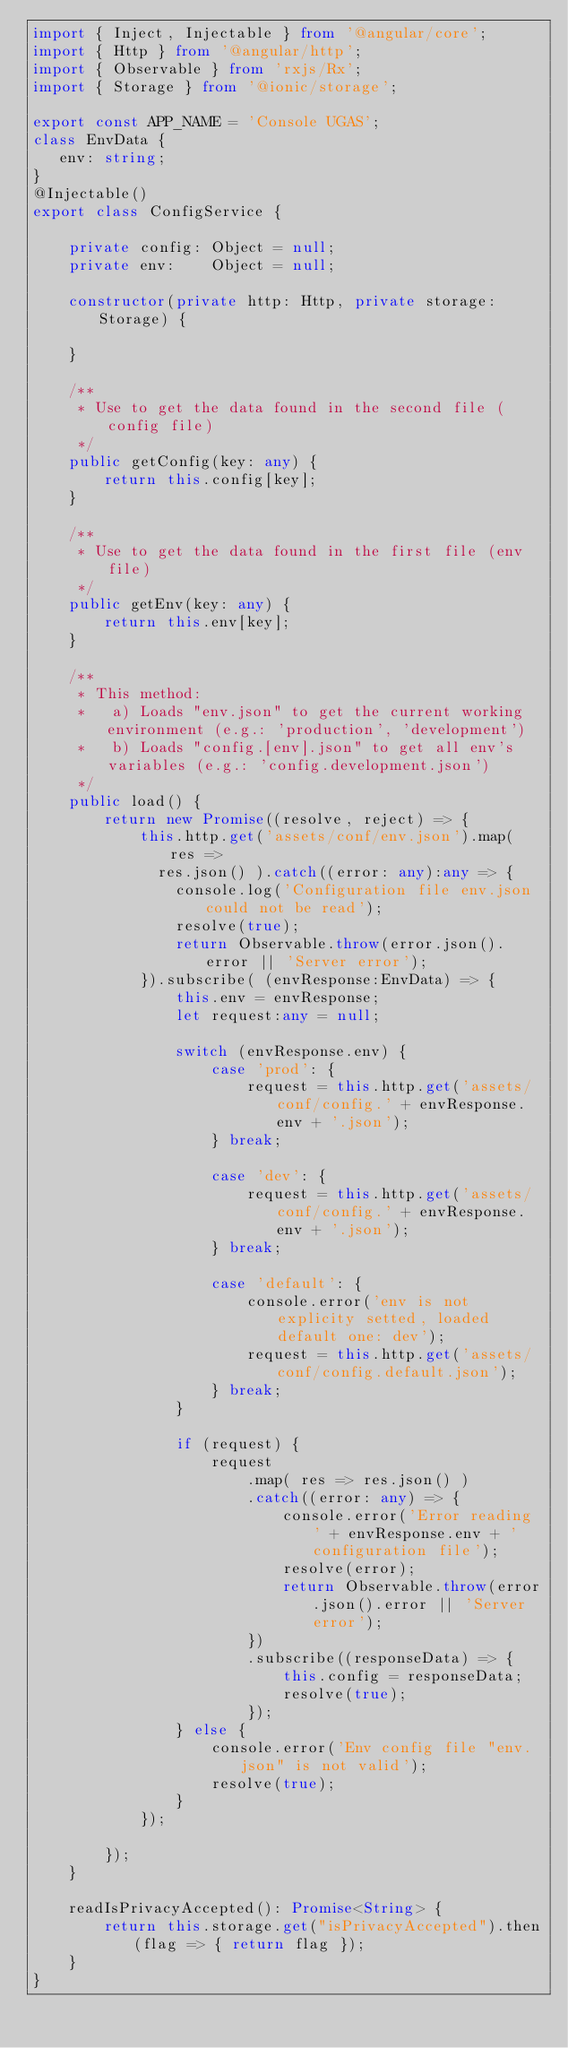Convert code to text. <code><loc_0><loc_0><loc_500><loc_500><_TypeScript_>import { Inject, Injectable } from '@angular/core';
import { Http } from '@angular/http';
import { Observable } from 'rxjs/Rx';
import { Storage } from '@ionic/storage';

export const APP_NAME = 'Console UGAS';
class EnvData {
   env: string;
}
@Injectable()
export class ConfigService {

    private config: Object = null;
    private env:    Object = null;

    constructor(private http: Http, private storage:Storage) {

    }

    /**
     * Use to get the data found in the second file (config file)
     */
    public getConfig(key: any) {
        return this.config[key];
    }

    /**
     * Use to get the data found in the first file (env file)
     */
    public getEnv(key: any) {
        return this.env[key];
    }

    /**
     * This method:
     *   a) Loads "env.json" to get the current working environment (e.g.: 'production', 'development')
     *   b) Loads "config.[env].json" to get all env's variables (e.g.: 'config.development.json')
     */
    public load() {
        return new Promise((resolve, reject) => {
            this.http.get('assets/conf/env.json').map( res =>
              res.json() ).catch((error: any):any => {
                console.log('Configuration file env.json could not be read');
                resolve(true);
                return Observable.throw(error.json().error || 'Server error');
            }).subscribe( (envResponse:EnvData) => {
                this.env = envResponse;
                let request:any = null;

                switch (envResponse.env) {
                    case 'prod': {
                        request = this.http.get('assets/conf/config.' + envResponse.env + '.json');
                    } break;

                    case 'dev': {
                        request = this.http.get('assets/conf/config.' + envResponse.env + '.json');
                    } break;

                    case 'default': {
                        console.error('env is not explicity setted, loaded default one: dev');
                        request = this.http.get('assets/conf/config.default.json');
                    } break;
                }

                if (request) {
                    request
                        .map( res => res.json() )
                        .catch((error: any) => {
                            console.error('Error reading ' + envResponse.env + ' configuration file');
                            resolve(error);
                            return Observable.throw(error.json().error || 'Server error');
                        })
                        .subscribe((responseData) => {
                            this.config = responseData;
                            resolve(true);
                        });
                } else {
                    console.error('Env config file "env.json" is not valid');
                    resolve(true);
                }
            });

        });
    }

    readIsPrivacyAccepted(): Promise<String> {
        return this.storage.get("isPrivacyAccepted").then(flag => { return flag });
    }
}
</code> 